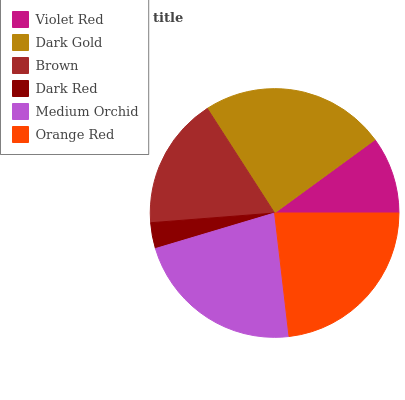Is Dark Red the minimum?
Answer yes or no. Yes. Is Dark Gold the maximum?
Answer yes or no. Yes. Is Brown the minimum?
Answer yes or no. No. Is Brown the maximum?
Answer yes or no. No. Is Dark Gold greater than Brown?
Answer yes or no. Yes. Is Brown less than Dark Gold?
Answer yes or no. Yes. Is Brown greater than Dark Gold?
Answer yes or no. No. Is Dark Gold less than Brown?
Answer yes or no. No. Is Medium Orchid the high median?
Answer yes or no. Yes. Is Brown the low median?
Answer yes or no. Yes. Is Violet Red the high median?
Answer yes or no. No. Is Dark Gold the low median?
Answer yes or no. No. 